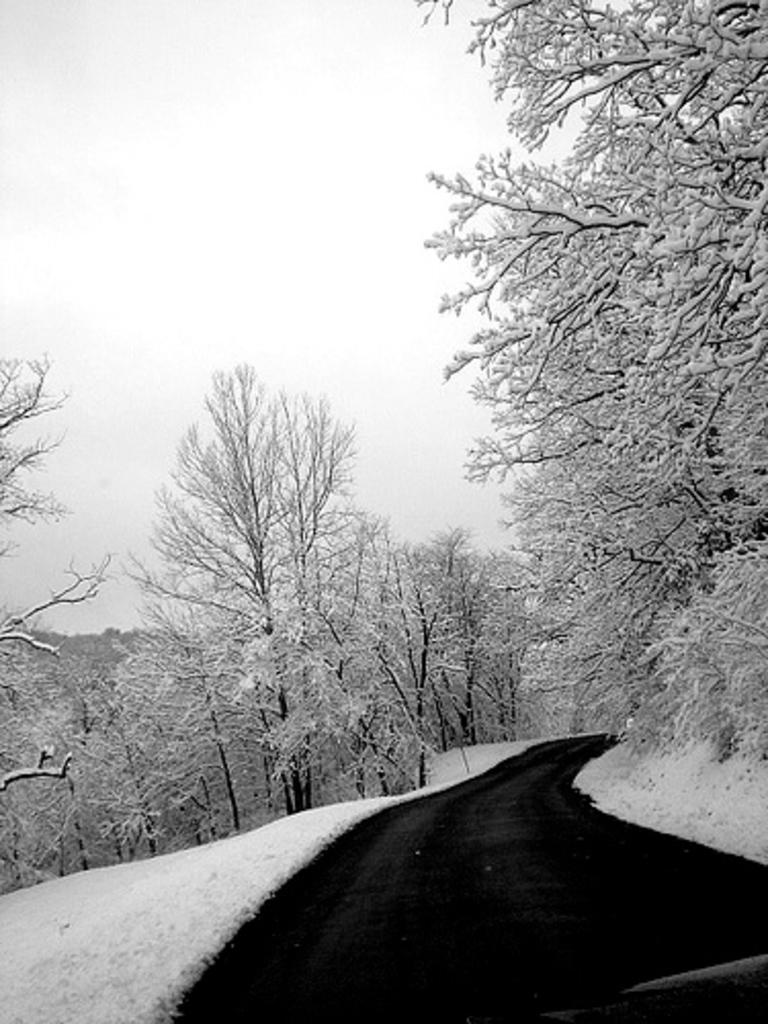What type of vegetation can be seen in the image? There are trees in the image. What is located between the trees? There is a road visible between the trees. What is the weather like in the image? Snow is present in the image, indicating a cold or wintery environment. What can be seen in the background of the image? The sky is visible in the background of the image. Where is the mine located in the image? There is no mine present in the image. Can you describe the beggar's clothing in the image? There is no beggar present in the image. 